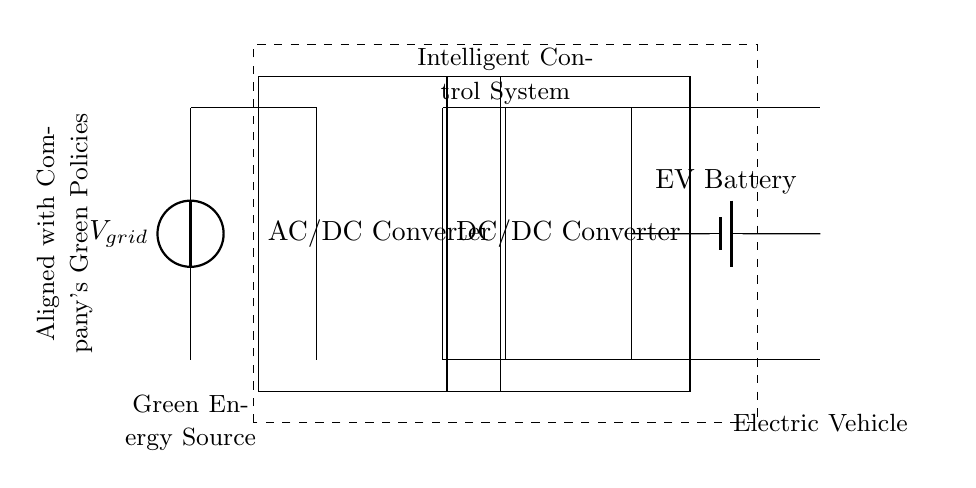What is the primary power source in this circuit? The primary power source is indicated as a voltage source labeled V_grid. This source feeds the AC/DC converter, converting grid AC power to DC.
Answer: V_grid What component converts AC to DC? The component that converts AC to DC is the AC/DC Converter, which is essential for charging electric vehicle batteries.
Answer: AC/DC Converter What is the purpose of the DC Bus in this circuit? The DC Bus serves as a central distribution point for the DC power generated by the AC/DC converter. It connects the converter output to the DC/DC converter and the electric vehicle battery.
Answer: Distribution point How many converters are used in this circuit? There are two converters in the circuit: one AC/DC Converter and one DC/DC Converter, each serving specific roles in converting and regulating power.
Answer: Two Which component directly interfaces with the Electric Vehicle? The component that directly interfaces with the Electric Vehicle is the EV Battery, which receives the regulated DC power from the DC Bus.
Answer: EV Battery What type of control is implemented in this circuit? The circuit uses an Intelligent Control System, indicated by the dashed rectangle, to manage the charging process efficiently and align with green policies.
Answer: Intelligent Control System How does this circuit align with company green policies? The alignment with green policies is represented by the note in the circuit diagram, emphasizing the use of renewable energy resources and efficient charging practices.
Answer: Renewable energy 